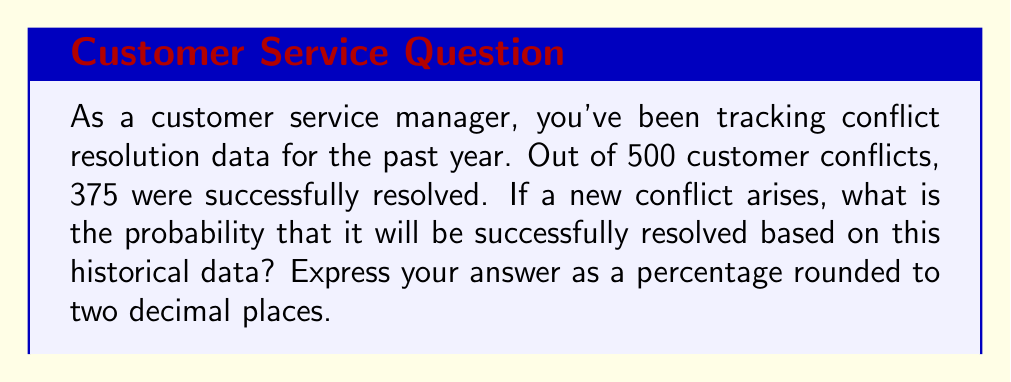Solve this math problem. To solve this problem, we need to use the concept of probability based on historical data. The probability of an event occurring is calculated by dividing the number of favorable outcomes by the total number of possible outcomes.

Let's break down the given information:
- Total number of conflicts: $n = 500$
- Number of successfully resolved conflicts: $k = 375$

The probability of successful conflict resolution can be calculated using the following formula:

$$P(\text{successful resolution}) = \frac{\text{number of successful resolutions}}{\text{total number of conflicts}}$$

Plugging in our values:

$$P(\text{successful resolution}) = \frac{375}{500}$$

To simplify this fraction:

$$P(\text{successful resolution}) = \frac{3}{4} = 0.75$$

To convert this to a percentage, we multiply by 100:

$$0.75 \times 100 = 75\%$$

Therefore, based on the historical data, there is a 75% chance that a new conflict will be successfully resolved.

Rounding to two decimal places doesn't change the result in this case, as it's already expressed with two decimal places.
Answer: 75.00% 